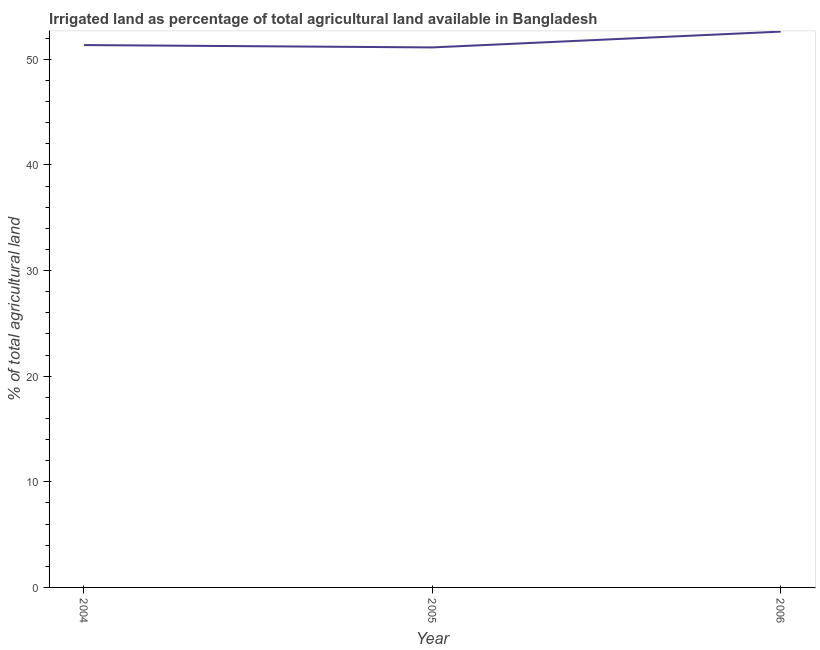What is the percentage of agricultural irrigated land in 2006?
Provide a short and direct response. 52.62. Across all years, what is the maximum percentage of agricultural irrigated land?
Provide a succinct answer. 52.62. Across all years, what is the minimum percentage of agricultural irrigated land?
Provide a short and direct response. 51.12. In which year was the percentage of agricultural irrigated land maximum?
Provide a succinct answer. 2006. In which year was the percentage of agricultural irrigated land minimum?
Make the answer very short. 2005. What is the sum of the percentage of agricultural irrigated land?
Make the answer very short. 155.09. What is the difference between the percentage of agricultural irrigated land in 2004 and 2006?
Provide a short and direct response. -1.27. What is the average percentage of agricultural irrigated land per year?
Provide a succinct answer. 51.7. What is the median percentage of agricultural irrigated land?
Offer a terse response. 51.35. Do a majority of the years between 2004 and 2005 (inclusive) have percentage of agricultural irrigated land greater than 8 %?
Make the answer very short. Yes. What is the ratio of the percentage of agricultural irrigated land in 2005 to that in 2006?
Give a very brief answer. 0.97. Is the percentage of agricultural irrigated land in 2005 less than that in 2006?
Offer a terse response. Yes. Is the difference between the percentage of agricultural irrigated land in 2005 and 2006 greater than the difference between any two years?
Make the answer very short. Yes. What is the difference between the highest and the second highest percentage of agricultural irrigated land?
Offer a terse response. 1.27. What is the difference between the highest and the lowest percentage of agricultural irrigated land?
Make the answer very short. 1.5. In how many years, is the percentage of agricultural irrigated land greater than the average percentage of agricultural irrigated land taken over all years?
Provide a succinct answer. 1. Does the percentage of agricultural irrigated land monotonically increase over the years?
Offer a very short reply. No. How many lines are there?
Offer a very short reply. 1. Does the graph contain grids?
Give a very brief answer. No. What is the title of the graph?
Your answer should be compact. Irrigated land as percentage of total agricultural land available in Bangladesh. What is the label or title of the Y-axis?
Your answer should be very brief. % of total agricultural land. What is the % of total agricultural land in 2004?
Provide a short and direct response. 51.35. What is the % of total agricultural land in 2005?
Your answer should be very brief. 51.12. What is the % of total agricultural land in 2006?
Your answer should be very brief. 52.62. What is the difference between the % of total agricultural land in 2004 and 2005?
Offer a terse response. 0.22. What is the difference between the % of total agricultural land in 2004 and 2006?
Offer a very short reply. -1.27. What is the difference between the % of total agricultural land in 2005 and 2006?
Offer a terse response. -1.5. What is the ratio of the % of total agricultural land in 2004 to that in 2006?
Offer a very short reply. 0.98. What is the ratio of the % of total agricultural land in 2005 to that in 2006?
Make the answer very short. 0.97. 